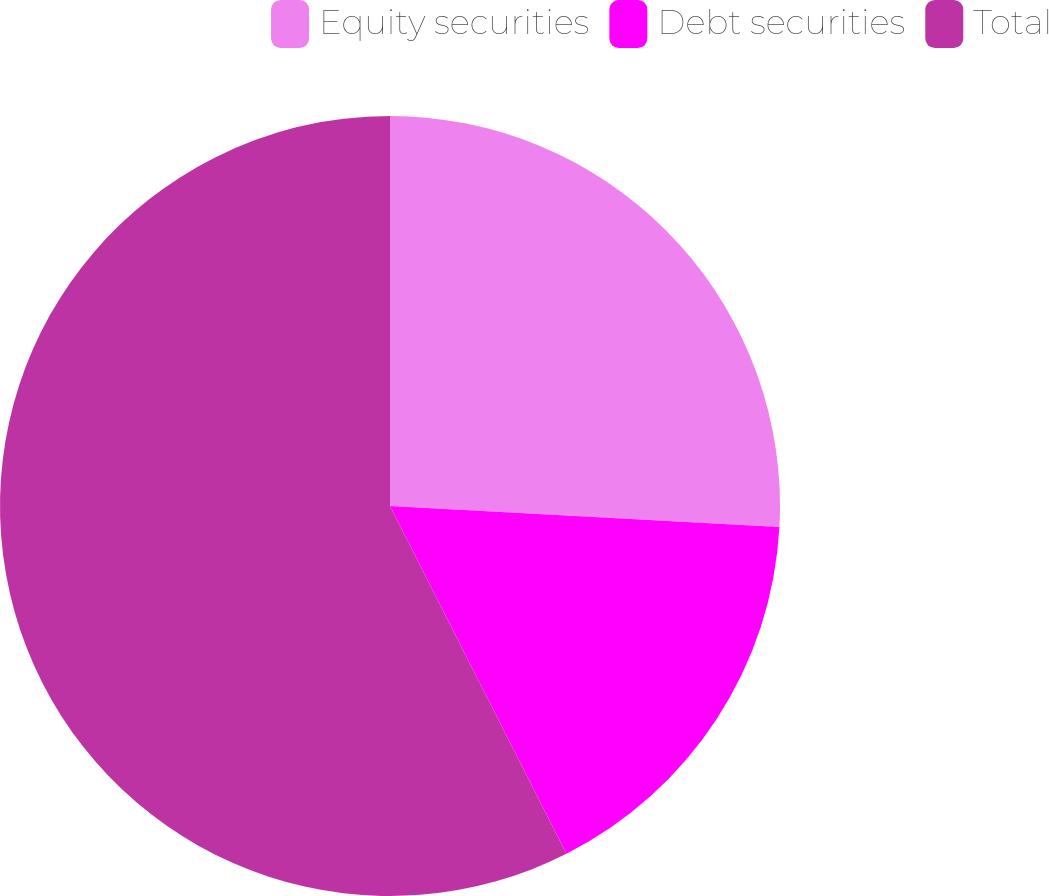Convert chart to OTSL. <chart><loc_0><loc_0><loc_500><loc_500><pie_chart><fcel>Equity securities<fcel>Debt securities<fcel>Total<nl><fcel>25.86%<fcel>16.67%<fcel>57.47%<nl></chart> 